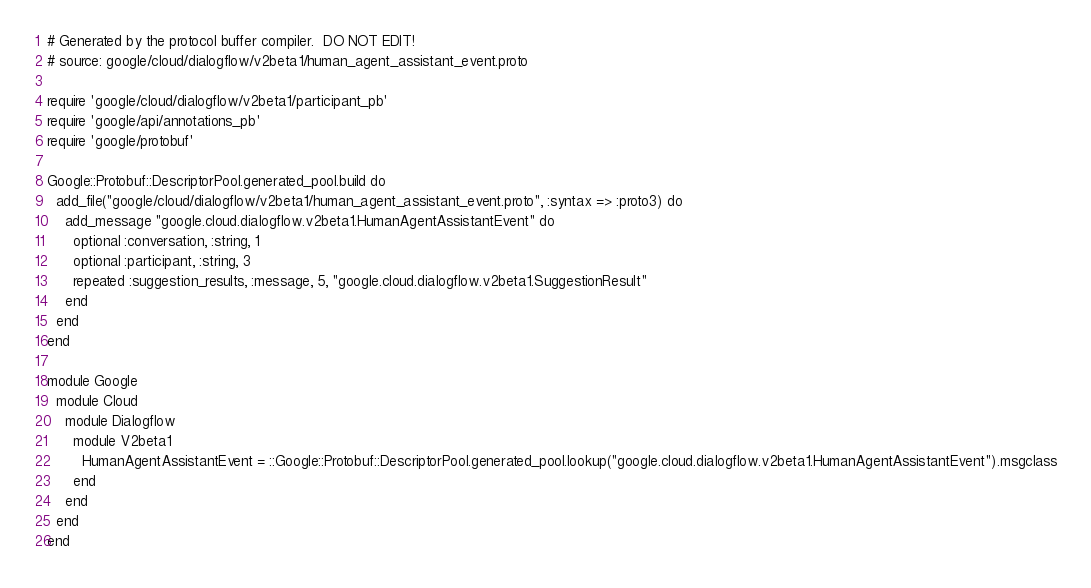Convert code to text. <code><loc_0><loc_0><loc_500><loc_500><_Ruby_># Generated by the protocol buffer compiler.  DO NOT EDIT!
# source: google/cloud/dialogflow/v2beta1/human_agent_assistant_event.proto

require 'google/cloud/dialogflow/v2beta1/participant_pb'
require 'google/api/annotations_pb'
require 'google/protobuf'

Google::Protobuf::DescriptorPool.generated_pool.build do
  add_file("google/cloud/dialogflow/v2beta1/human_agent_assistant_event.proto", :syntax => :proto3) do
    add_message "google.cloud.dialogflow.v2beta1.HumanAgentAssistantEvent" do
      optional :conversation, :string, 1
      optional :participant, :string, 3
      repeated :suggestion_results, :message, 5, "google.cloud.dialogflow.v2beta1.SuggestionResult"
    end
  end
end

module Google
  module Cloud
    module Dialogflow
      module V2beta1
        HumanAgentAssistantEvent = ::Google::Protobuf::DescriptorPool.generated_pool.lookup("google.cloud.dialogflow.v2beta1.HumanAgentAssistantEvent").msgclass
      end
    end
  end
end
</code> 